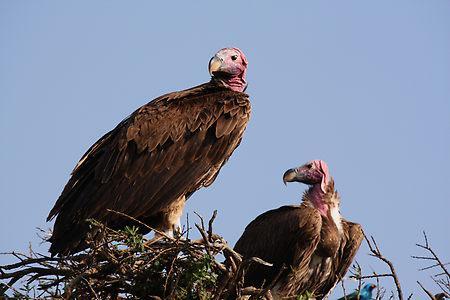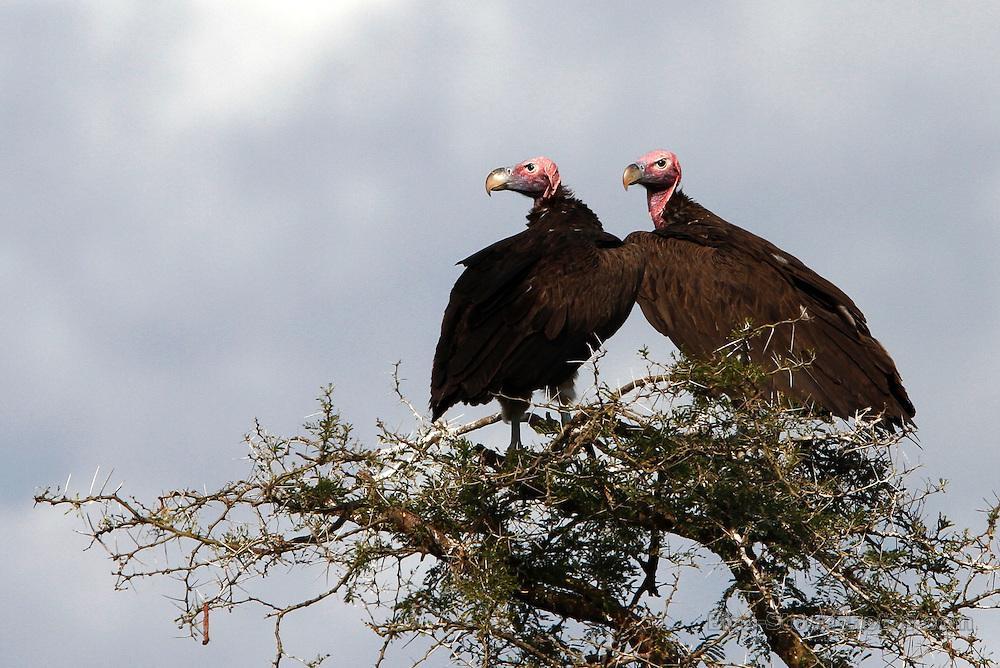The first image is the image on the left, the second image is the image on the right. Assess this claim about the two images: "An image contains no more than one vulture.". Correct or not? Answer yes or no. No. The first image is the image on the left, the second image is the image on the right. Given the left and right images, does the statement "Two birds are perched on a branch in the image on the right." hold true? Answer yes or no. Yes. 